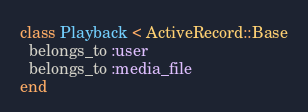<code> <loc_0><loc_0><loc_500><loc_500><_Ruby_>class Playback < ActiveRecord::Base
  belongs_to :user
  belongs_to :media_file
end
</code> 